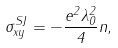Convert formula to latex. <formula><loc_0><loc_0><loc_500><loc_500>\sigma _ { x y } ^ { S J } = - \frac { e ^ { 2 } \lambda _ { 0 } ^ { 2 } } { 4 } n ,</formula> 